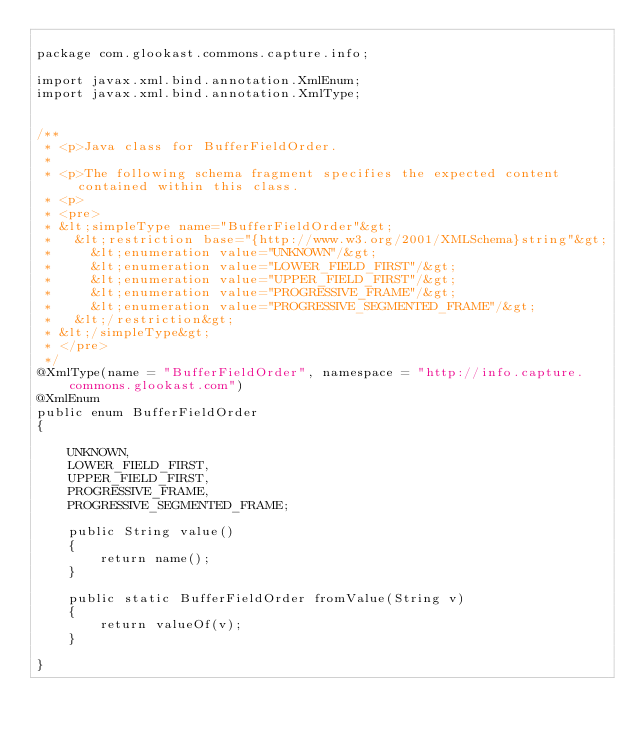<code> <loc_0><loc_0><loc_500><loc_500><_Java_>
package com.glookast.commons.capture.info;

import javax.xml.bind.annotation.XmlEnum;
import javax.xml.bind.annotation.XmlType;


/**
 * <p>Java class for BufferFieldOrder.
 *
 * <p>The following schema fragment specifies the expected content contained within this class.
 * <p>
 * <pre>
 * &lt;simpleType name="BufferFieldOrder"&gt;
 *   &lt;restriction base="{http://www.w3.org/2001/XMLSchema}string"&gt;
 *     &lt;enumeration value="UNKNOWN"/&gt;
 *     &lt;enumeration value="LOWER_FIELD_FIRST"/&gt;
 *     &lt;enumeration value="UPPER_FIELD_FIRST"/&gt;
 *     &lt;enumeration value="PROGRESSIVE_FRAME"/&gt;
 *     &lt;enumeration value="PROGRESSIVE_SEGMENTED_FRAME"/&gt;
 *   &lt;/restriction&gt;
 * &lt;/simpleType&gt;
 * </pre>
 */
@XmlType(name = "BufferFieldOrder", namespace = "http://info.capture.commons.glookast.com")
@XmlEnum
public enum BufferFieldOrder
{

    UNKNOWN,
    LOWER_FIELD_FIRST,
    UPPER_FIELD_FIRST,
    PROGRESSIVE_FRAME,
    PROGRESSIVE_SEGMENTED_FRAME;

    public String value()
    {
        return name();
    }

    public static BufferFieldOrder fromValue(String v)
    {
        return valueOf(v);
    }

}
</code> 